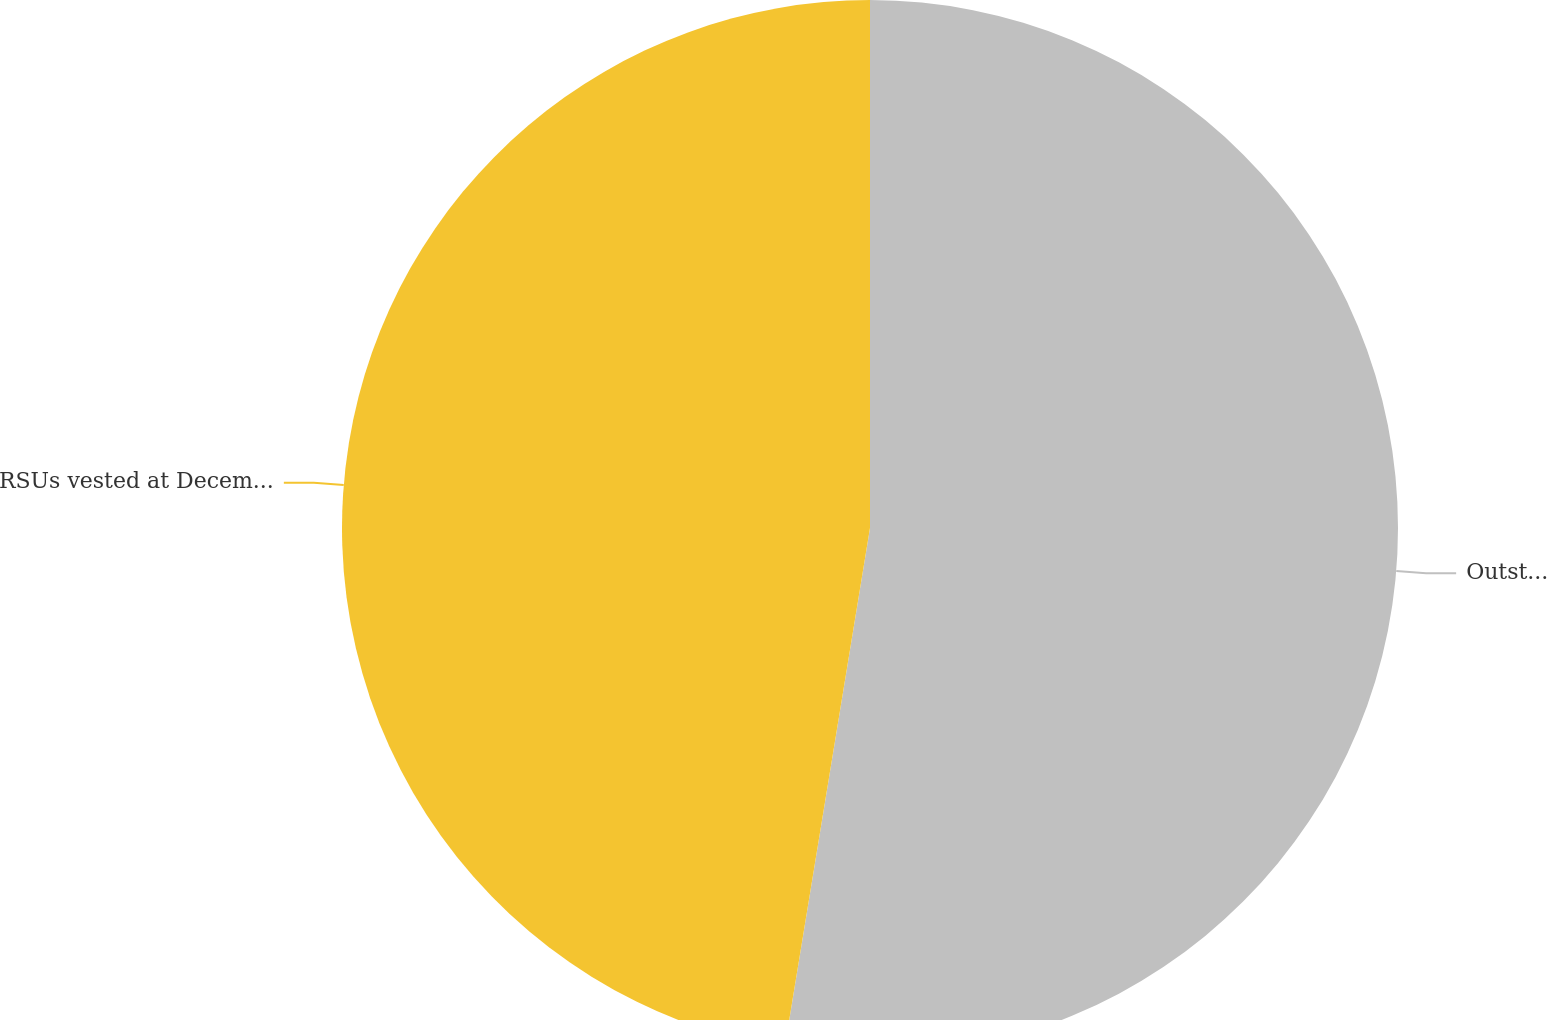Convert chart. <chart><loc_0><loc_0><loc_500><loc_500><pie_chart><fcel>Outstanding at December 31<fcel>RSUs vested at December 31<nl><fcel>52.59%<fcel>47.41%<nl></chart> 